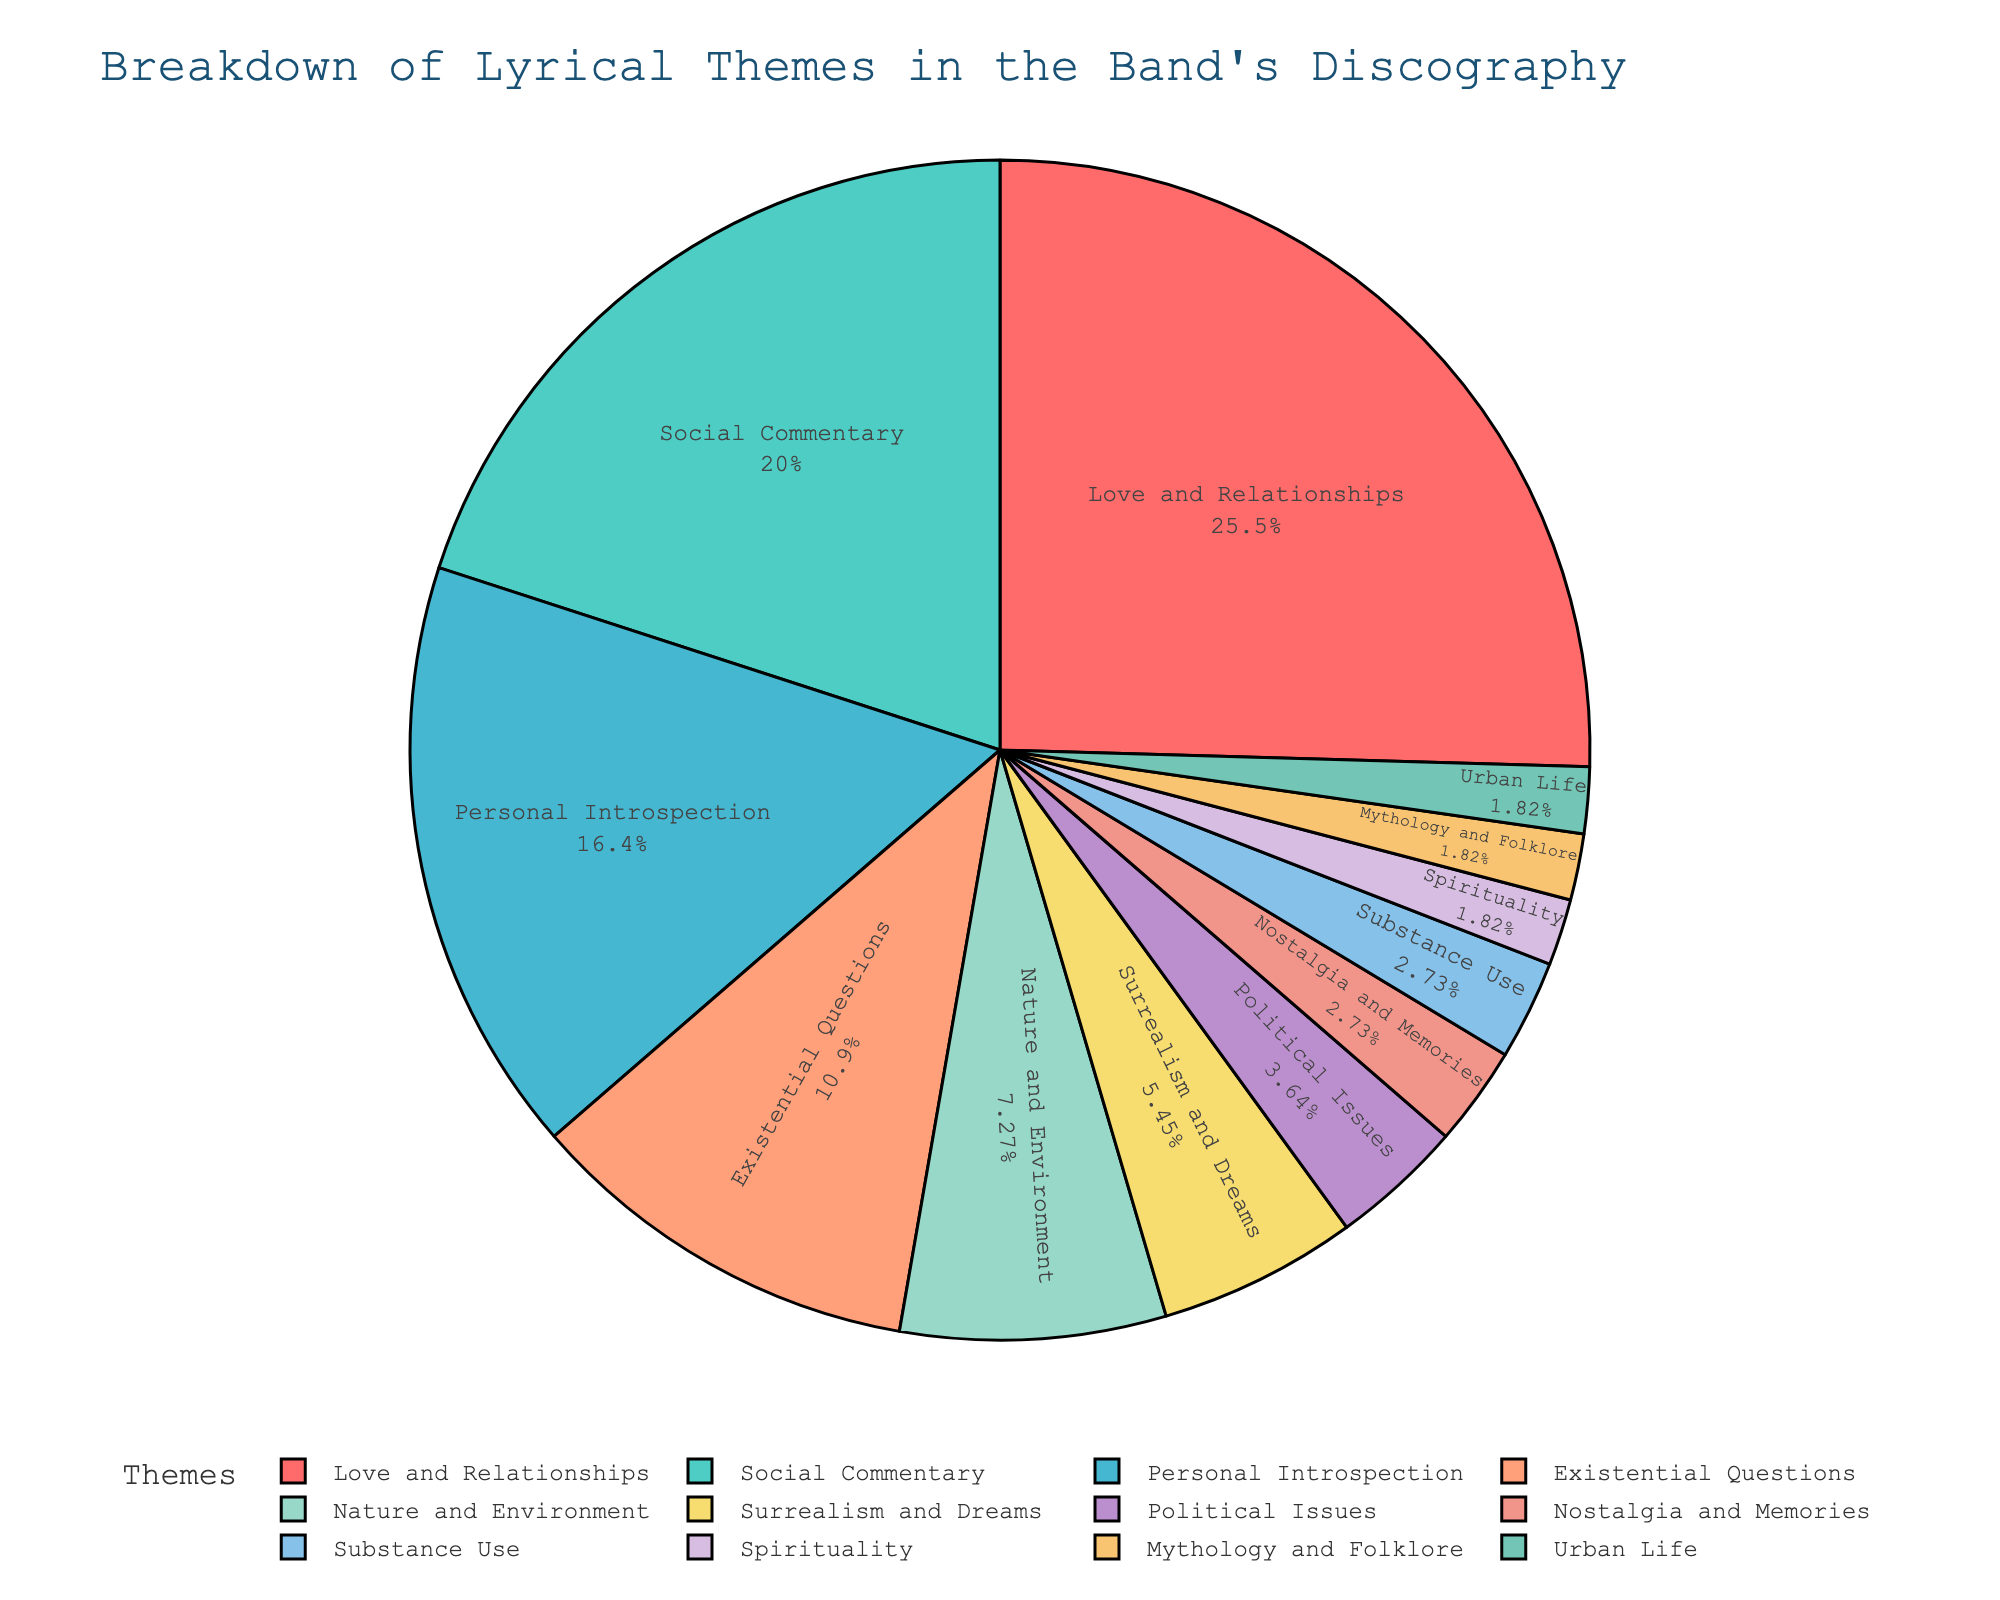Which lyrical theme has the highest percentage in the band's discography? The pie chart shows different segments representing various lyrical themes. By looking at the segment with the largest area, we see that "Love and Relationships" has the highest percentage.
Answer: Love and Relationships What is the combined percentage of "Social Commentary" and "Existential Questions"? To find the combined percentage, we add the individual percentages of the two themes: 22% (Social Commentary) + 12% (Existential Questions) = 34%.
Answer: 34% Which theme has a larger percentage, "Personal Introspection" or "Nature and Environment"? By comparing the two sections of the pie chart for the given themes, we see that "Personal Introspection" has a larger percentage (18%) compared to "Nature and Environment" (8%).
Answer: Personal Introspection What percentage of the band's discography is made up of themes related to "nostalgia"? To find this, locate the segment labeled "Nostalgia and Memories" in the pie chart, which shows a percentage of 3%.
Answer: 3% How does the percentage of "Surrealism and Dreams" compare to "Political Issues"? By checking the respective portions of the pie chart, "Surrealism and Dreams" has a higher percentage (6%) than "Political Issues" (4%).
Answer: Surrealism and Dreams What is the total percentage of themes that have less than 5% each? Add the percentages of themes with less than 5%: "Political Issues" (4%), "Nostalgia and Memories" (3%), "Substance Use" (3%), "Spirituality" (2%), "Mythology and Folklore" (2%), and "Urban Life" (2%). The total is 4 + 3 + 3 + 2 + 2 + 2 = 16%.
Answer: 16% Which color represents "Existential Questions" on the pie chart? By matching the colors to the labels, we find that "Existential Questions" is represented by the color orange.
Answer: Orange What percentage more does "Love and Relationships" have compared to "Nature and Environment"? Subtract the percentage of "Nature and Environment" from "Love and Relationships": 28% - 8% = 20%.
Answer: 20% Is "Substance Use" one of the least represented themes? By looking at the pie chart, "Substance Use" is one of the smaller segments, at 3%, which places it among the least represented themes.
Answer: Yes What's the difference in percentage between "Mythology and Folklore" and "Spirituality"? Subtract the percentage of "Spirituality" from "Mythology and Folklore": 2% - 2% = 0%.
Answer: 0% 